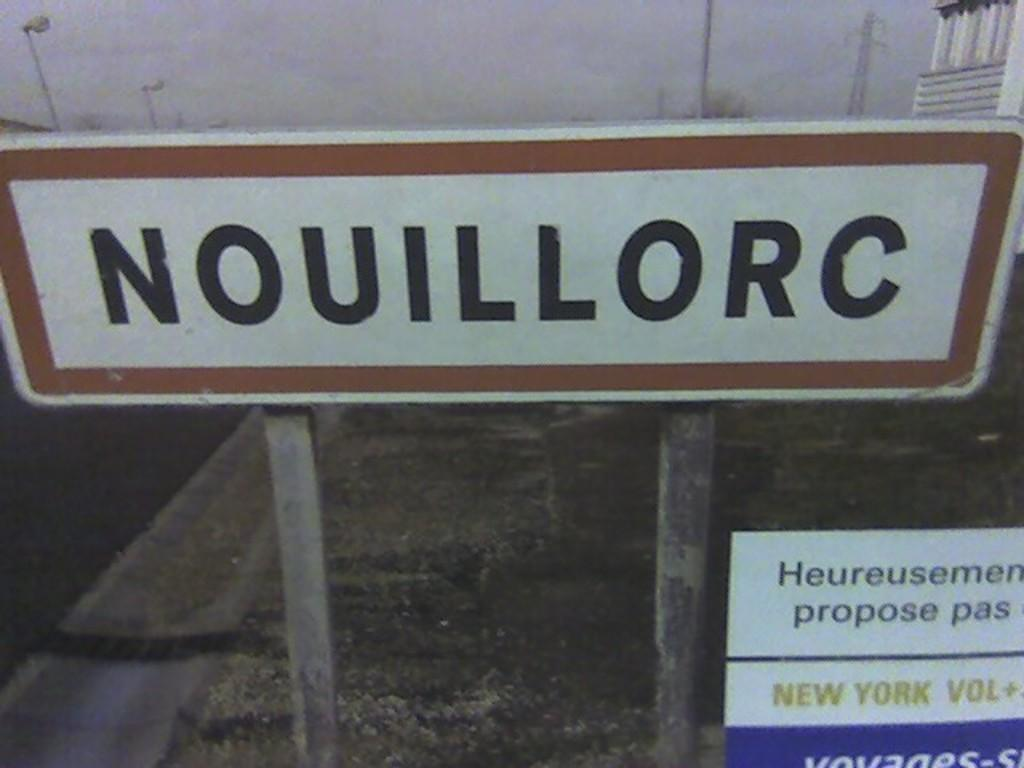<image>
Present a compact description of the photo's key features. A brown white rectangular sign has the text nouillorc on it in black font. 